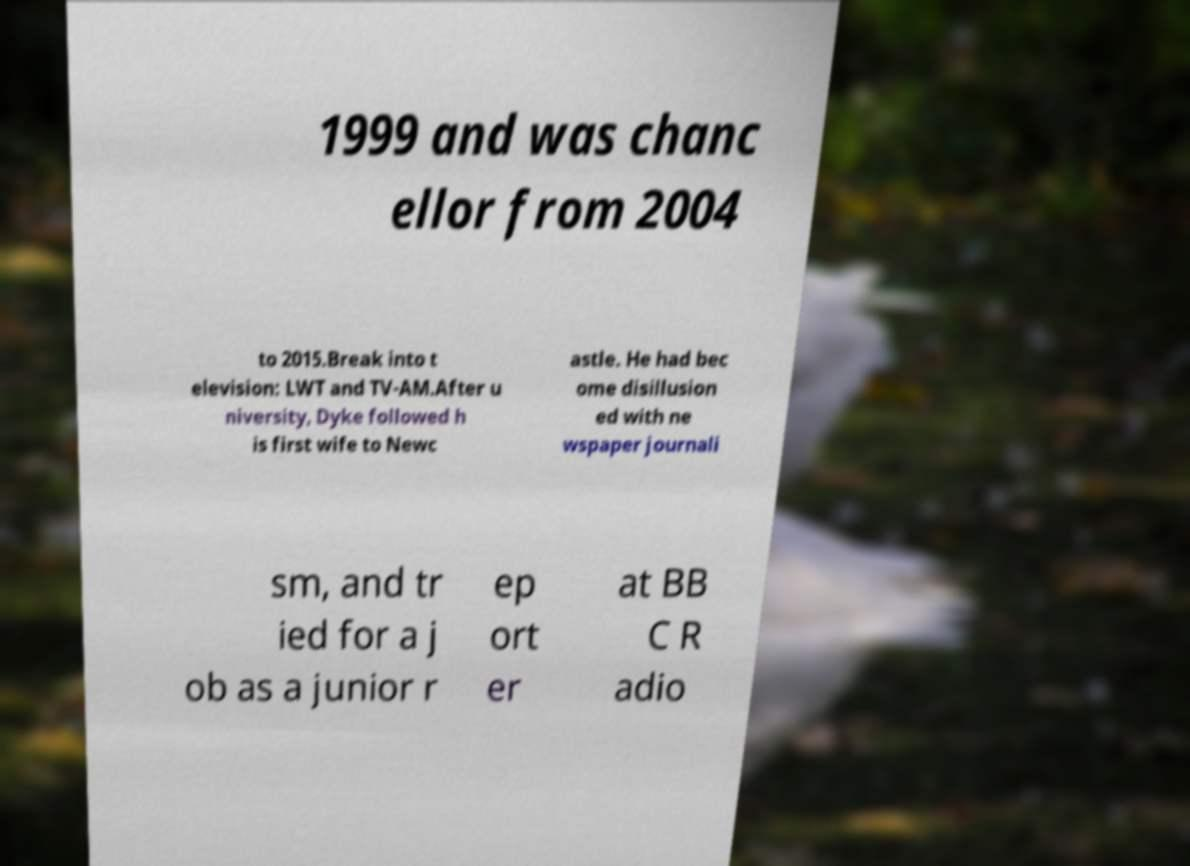There's text embedded in this image that I need extracted. Can you transcribe it verbatim? 1999 and was chanc ellor from 2004 to 2015.Break into t elevision: LWT and TV-AM.After u niversity, Dyke followed h is first wife to Newc astle. He had bec ome disillusion ed with ne wspaper journali sm, and tr ied for a j ob as a junior r ep ort er at BB C R adio 